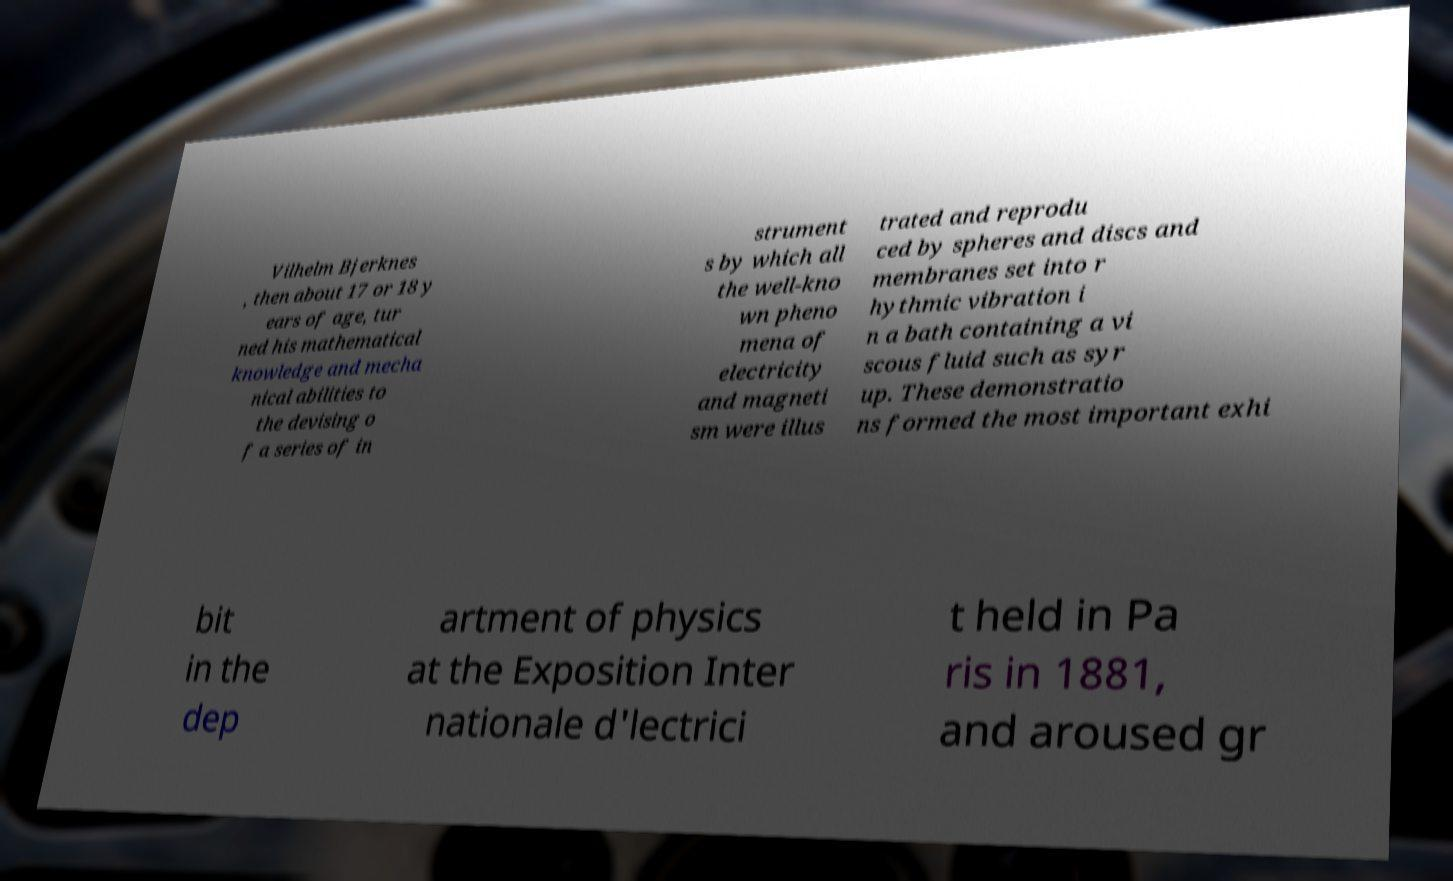Please identify and transcribe the text found in this image. Vilhelm Bjerknes , then about 17 or 18 y ears of age, tur ned his mathematical knowledge and mecha nical abilities to the devising o f a series of in strument s by which all the well-kno wn pheno mena of electricity and magneti sm were illus trated and reprodu ced by spheres and discs and membranes set into r hythmic vibration i n a bath containing a vi scous fluid such as syr up. These demonstratio ns formed the most important exhi bit in the dep artment of physics at the Exposition Inter nationale d'lectrici t held in Pa ris in 1881, and aroused gr 